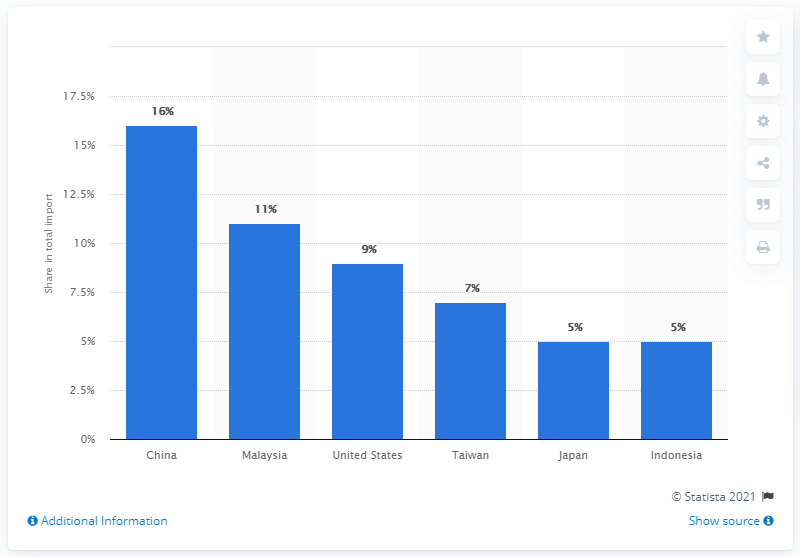Give some essential details in this illustration. In 2019, China was the most significant import partner for Singapore. 